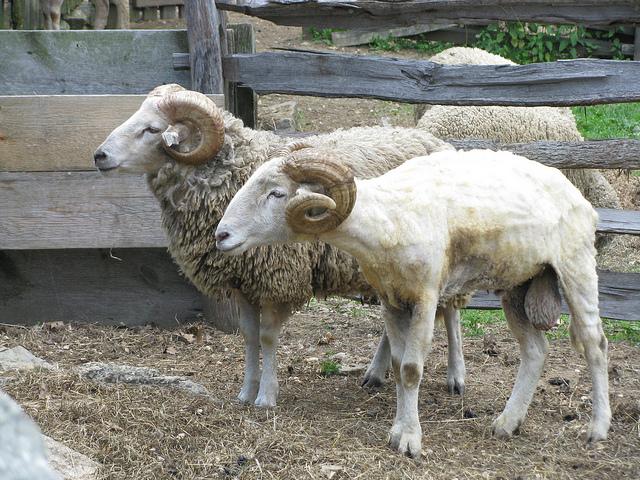What material is the fence made of?
Quick response, please. Wood. What are these animals?
Write a very short answer. Rams. What are the animals doing?
Answer briefly. Standing. What animals are these?
Answer briefly. Sheep. Are the sheeps horns curled?
Give a very brief answer. Yes. Is he standing on grass?
Answer briefly. No. Are the animals the same age?
Give a very brief answer. No. 